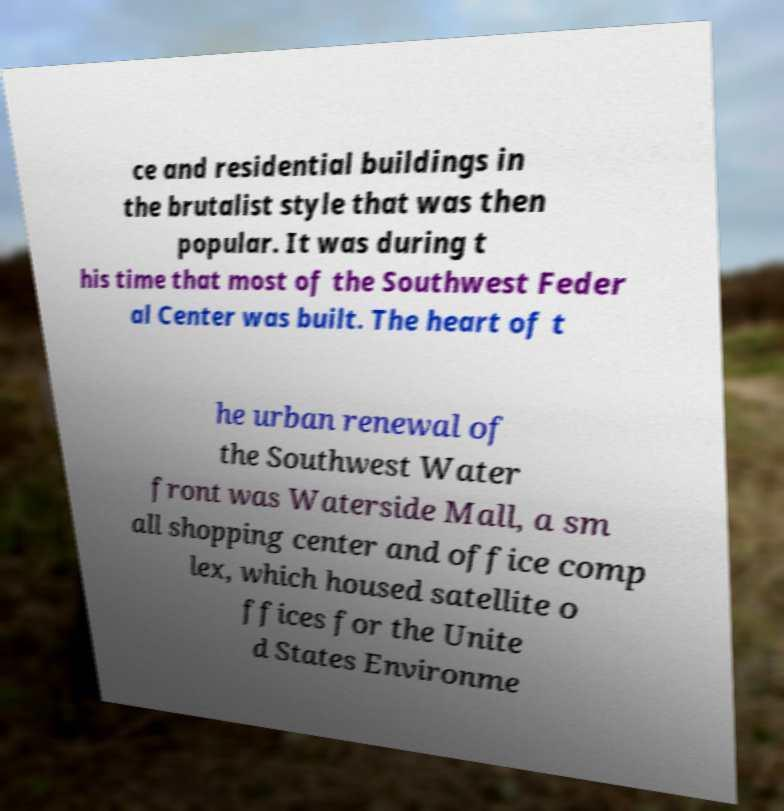What messages or text are displayed in this image? I need them in a readable, typed format. ce and residential buildings in the brutalist style that was then popular. It was during t his time that most of the Southwest Feder al Center was built. The heart of t he urban renewal of the Southwest Water front was Waterside Mall, a sm all shopping center and office comp lex, which housed satellite o ffices for the Unite d States Environme 